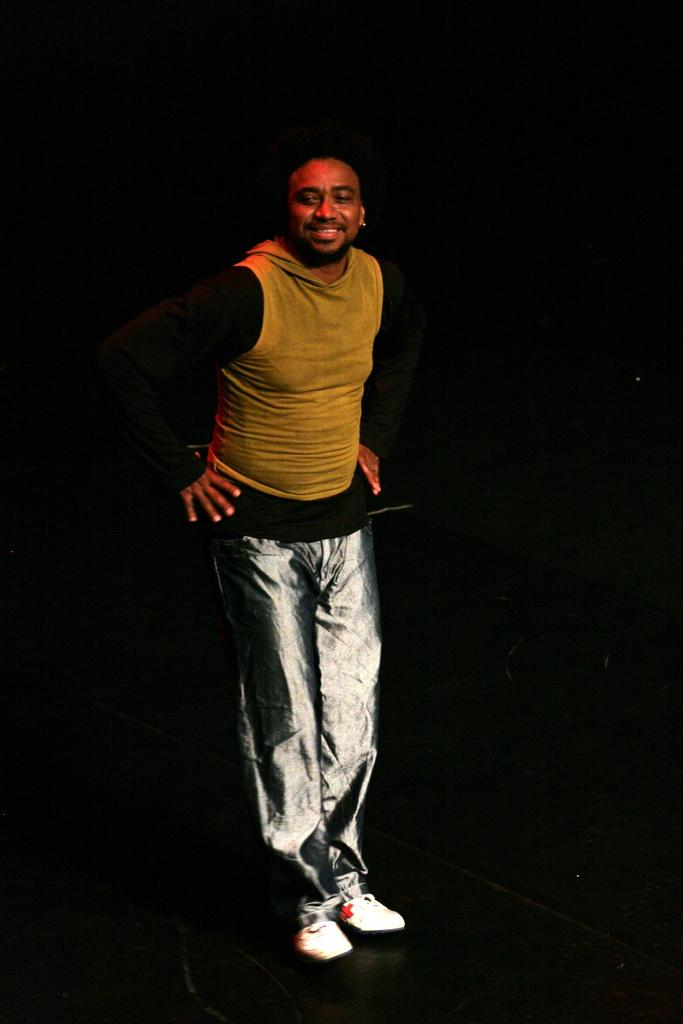What is the main subject of the image? There is a person in the image. What is the person wearing? The person is wearing a T-shirt. What is the person's facial expression? The person is smiling. Where is the person located in the image? The person is performing on a stage. What is the color of the background in the image? The background of the image is dark in color. What type of circle can be seen in the image? There is no circle present in the image. What is the person riding on the stage in the image? The person is performing on a stage, but there is no mention of a tank or any other vehicle in the image. 